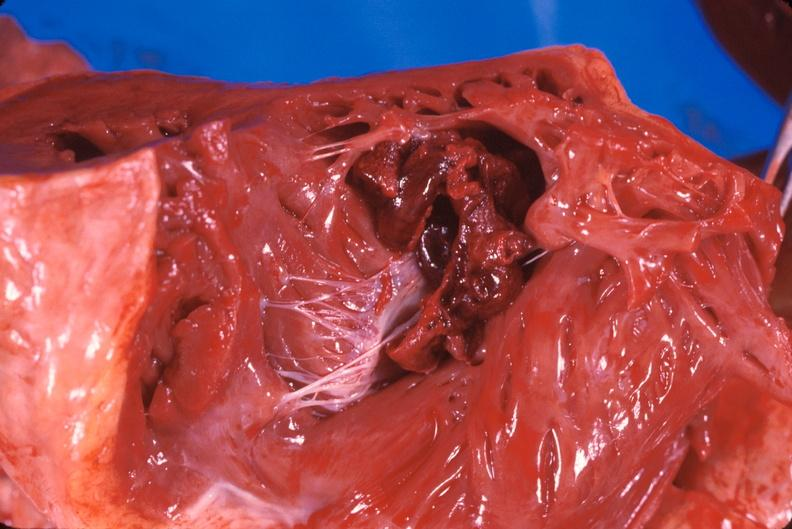what is present?
Answer the question using a single word or phrase. Cardiovascular 